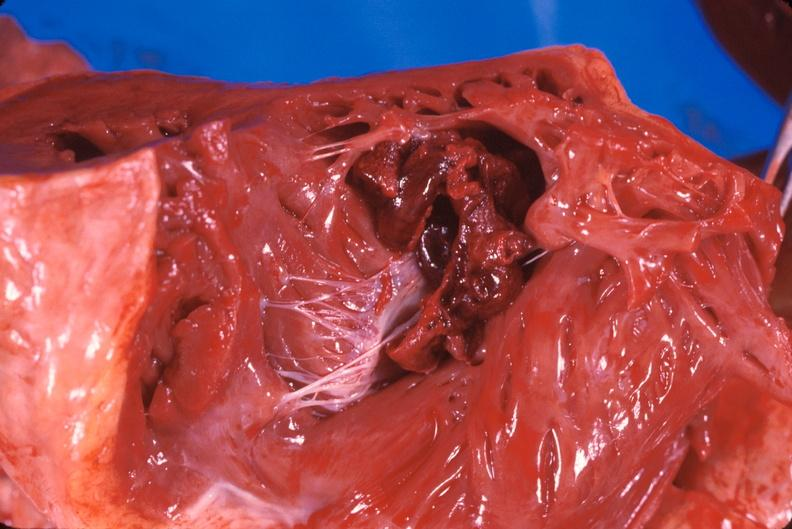what is present?
Answer the question using a single word or phrase. Cardiovascular 